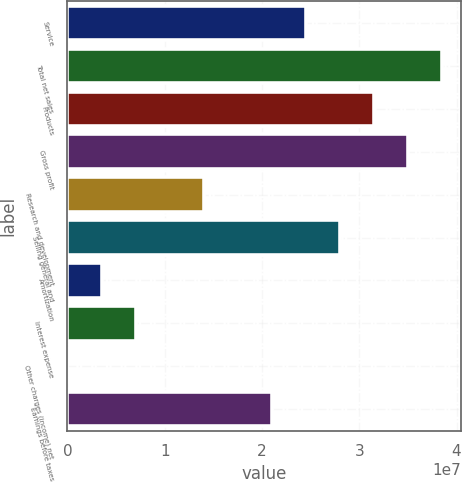Convert chart. <chart><loc_0><loc_0><loc_500><loc_500><bar_chart><fcel>Service<fcel>Total net sales<fcel>Products<fcel>Gross profit<fcel>Research and development<fcel>Selling general and<fcel>Amortization<fcel>Interest expense<fcel>Other charges (income) net<fcel>Earnings before taxes<nl><fcel>2.45369e+07<fcel>3.85528e+07<fcel>3.15449e+07<fcel>3.50489e+07<fcel>1.40249e+07<fcel>2.80409e+07<fcel>3.51297e+06<fcel>7.01696e+06<fcel>8981<fcel>2.10329e+07<nl></chart> 